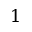Convert formula to latex. <formula><loc_0><loc_0><loc_500><loc_500>1</formula> 